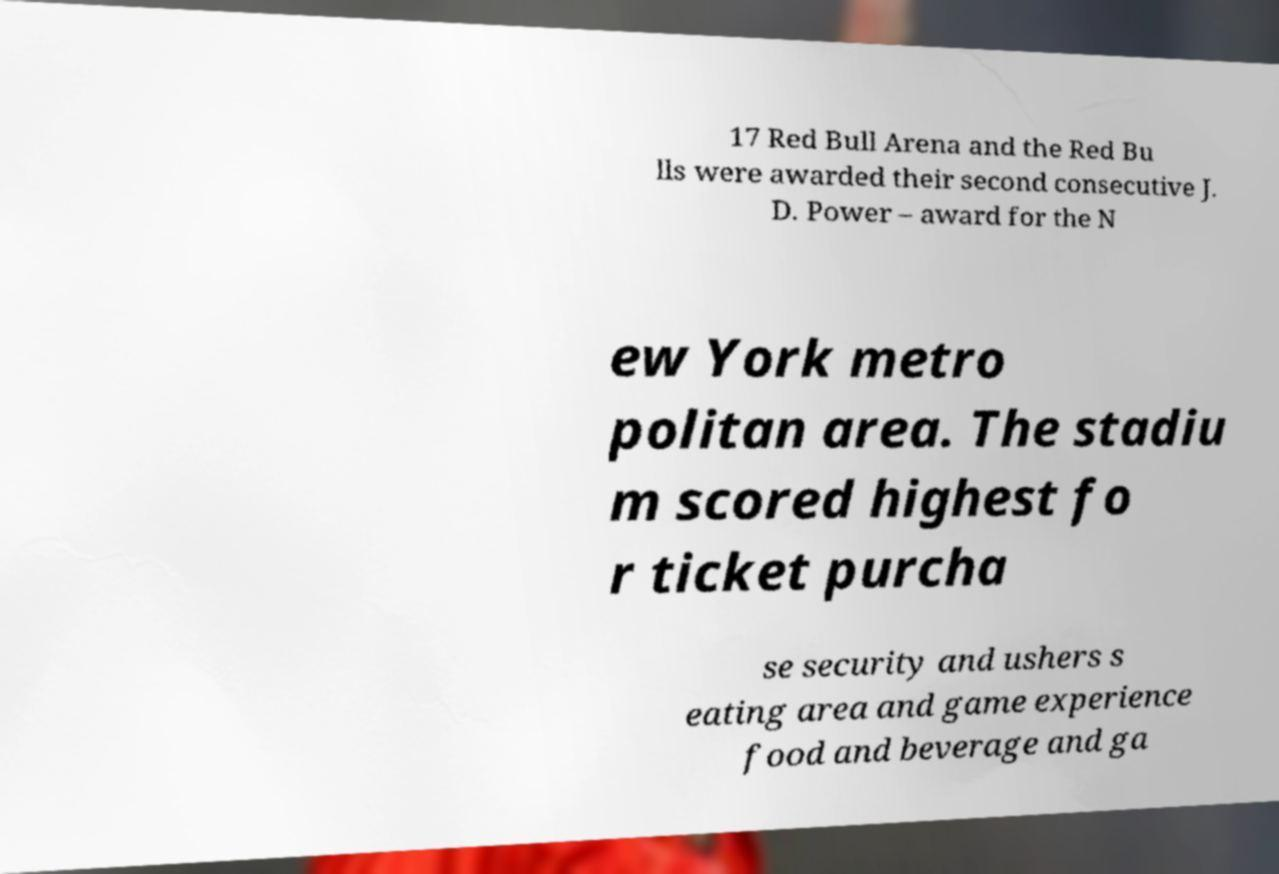There's text embedded in this image that I need extracted. Can you transcribe it verbatim? 17 Red Bull Arena and the Red Bu lls were awarded their second consecutive J. D. Power – award for the N ew York metro politan area. The stadiu m scored highest fo r ticket purcha se security and ushers s eating area and game experience food and beverage and ga 